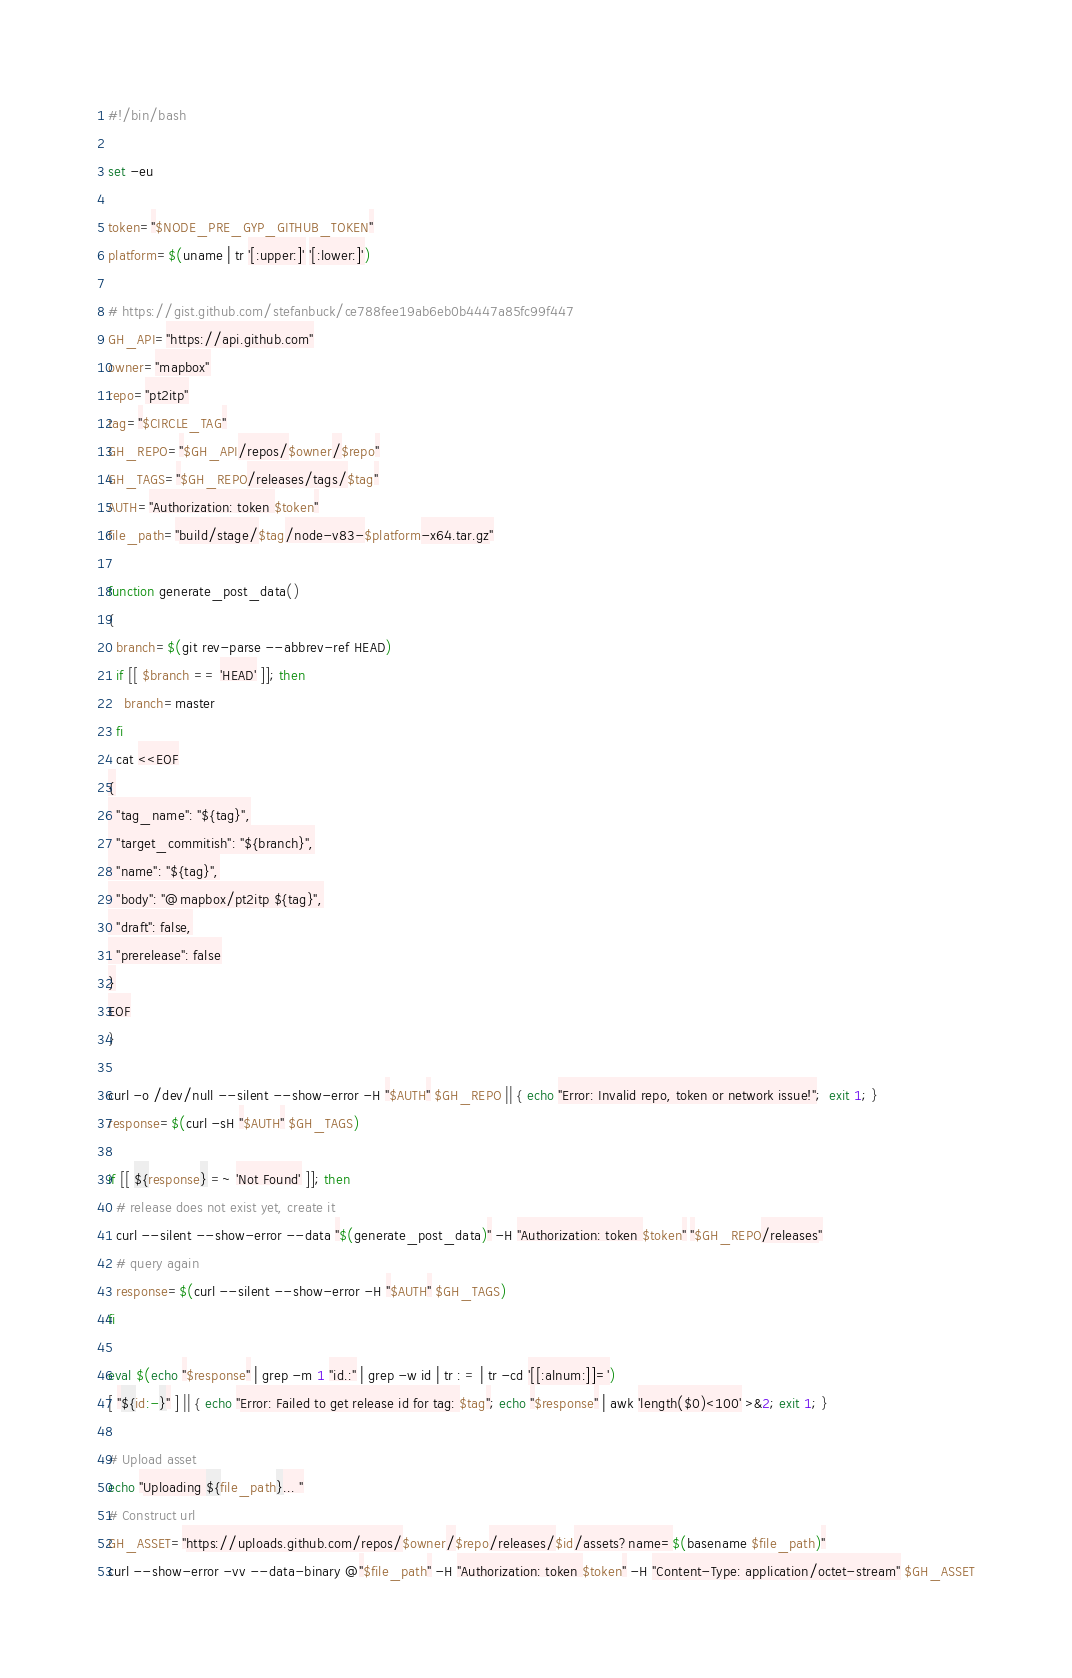Convert code to text. <code><loc_0><loc_0><loc_500><loc_500><_Bash_>#!/bin/bash

set -eu

token="$NODE_PRE_GYP_GITHUB_TOKEN"
platform=$(uname | tr '[:upper:]' '[:lower:]')

# https://gist.github.com/stefanbuck/ce788fee19ab6eb0b4447a85fc99f447
GH_API="https://api.github.com"
owner="mapbox"
repo="pt2itp"
tag="$CIRCLE_TAG"
GH_REPO="$GH_API/repos/$owner/$repo"
GH_TAGS="$GH_REPO/releases/tags/$tag"
AUTH="Authorization: token $token"
file_path="build/stage/$tag/node-v83-$platform-x64.tar.gz"

function generate_post_data()
{
  branch=$(git rev-parse --abbrev-ref HEAD)
  if [[ $branch == 'HEAD' ]]; then
    branch=master
  fi
  cat <<EOF
{
  "tag_name": "${tag}",
  "target_commitish": "${branch}",
  "name": "${tag}",
  "body": "@mapbox/pt2itp ${tag}",
  "draft": false,
  "prerelease": false
}
EOF
}

curl -o /dev/null --silent --show-error -H "$AUTH" $GH_REPO || { echo "Error: Invalid repo, token or network issue!";  exit 1; }
response=$(curl -sH "$AUTH" $GH_TAGS)

if [[ ${response} =~ 'Not Found' ]]; then
  # release does not exist yet, create it
  curl --silent --show-error --data "$(generate_post_data)" -H "Authorization: token $token" "$GH_REPO/releases"
  # query again
  response=$(curl --silent --show-error -H "$AUTH" $GH_TAGS)
fi

eval $(echo "$response" | grep -m 1 "id.:" | grep -w id | tr : = | tr -cd '[[:alnum:]]=')
[ "${id:-}" ] || { echo "Error: Failed to get release id for tag: $tag"; echo "$response" | awk 'length($0)<100' >&2; exit 1; }

# Upload asset
echo "Uploading ${file_path}... "
# Construct url
GH_ASSET="https://uploads.github.com/repos/$owner/$repo/releases/$id/assets?name=$(basename $file_path)"
curl --show-error -vv --data-binary @"$file_path" -H "Authorization: token $token" -H "Content-Type: application/octet-stream" $GH_ASSET
</code> 